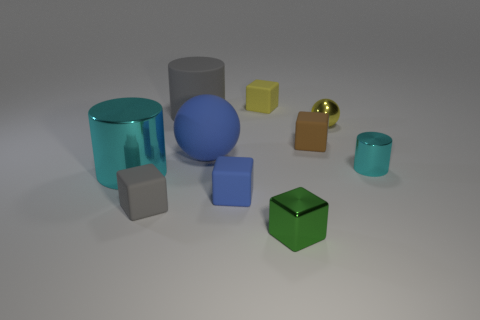Is the color of the big cylinder in front of the tiny cyan shiny cylinder the same as the small cylinder?
Your answer should be compact. Yes. There is a cyan thing to the right of the cyan object left of the yellow thing left of the brown matte object; what is it made of?
Offer a terse response. Metal. Is the size of the blue ball the same as the gray cylinder?
Make the answer very short. Yes. There is a big shiny thing; is it the same color as the cylinder that is on the right side of the small brown block?
Give a very brief answer. Yes. What is the shape of the tiny blue object that is the same material as the brown object?
Your answer should be very brief. Cube. Do the metallic thing to the right of the metal sphere and the big shiny object have the same shape?
Your answer should be very brief. Yes. There is a ball that is in front of the rubber thing that is right of the tiny metal cube; how big is it?
Your response must be concise. Large. What color is the cube that is the same material as the tiny ball?
Keep it short and to the point. Green. How many blue objects are the same size as the yellow matte cube?
Keep it short and to the point. 1. How many brown things are big rubber objects or small metallic things?
Make the answer very short. 0. 